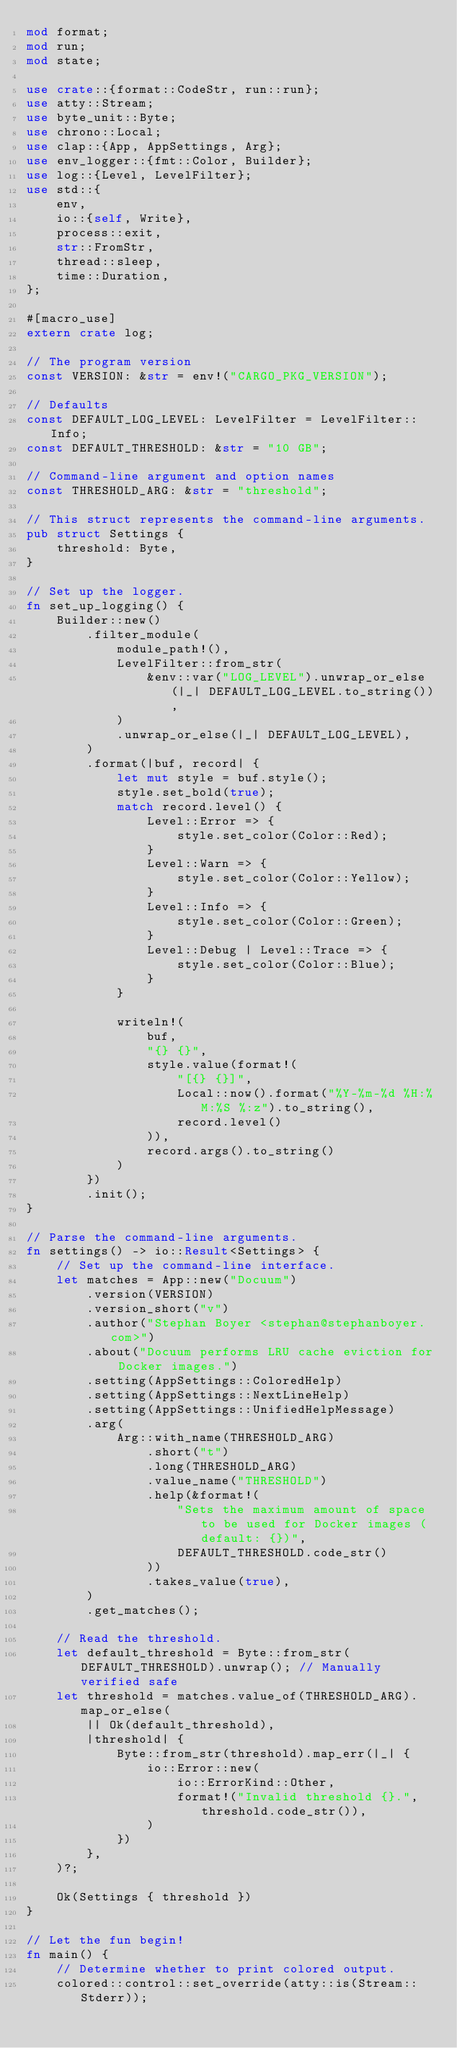Convert code to text. <code><loc_0><loc_0><loc_500><loc_500><_Rust_>mod format;
mod run;
mod state;

use crate::{format::CodeStr, run::run};
use atty::Stream;
use byte_unit::Byte;
use chrono::Local;
use clap::{App, AppSettings, Arg};
use env_logger::{fmt::Color, Builder};
use log::{Level, LevelFilter};
use std::{
    env,
    io::{self, Write},
    process::exit,
    str::FromStr,
    thread::sleep,
    time::Duration,
};

#[macro_use]
extern crate log;

// The program version
const VERSION: &str = env!("CARGO_PKG_VERSION");

// Defaults
const DEFAULT_LOG_LEVEL: LevelFilter = LevelFilter::Info;
const DEFAULT_THRESHOLD: &str = "10 GB";

// Command-line argument and option names
const THRESHOLD_ARG: &str = "threshold";

// This struct represents the command-line arguments.
pub struct Settings {
    threshold: Byte,
}

// Set up the logger.
fn set_up_logging() {
    Builder::new()
        .filter_module(
            module_path!(),
            LevelFilter::from_str(
                &env::var("LOG_LEVEL").unwrap_or_else(|_| DEFAULT_LOG_LEVEL.to_string()),
            )
            .unwrap_or_else(|_| DEFAULT_LOG_LEVEL),
        )
        .format(|buf, record| {
            let mut style = buf.style();
            style.set_bold(true);
            match record.level() {
                Level::Error => {
                    style.set_color(Color::Red);
                }
                Level::Warn => {
                    style.set_color(Color::Yellow);
                }
                Level::Info => {
                    style.set_color(Color::Green);
                }
                Level::Debug | Level::Trace => {
                    style.set_color(Color::Blue);
                }
            }

            writeln!(
                buf,
                "{} {}",
                style.value(format!(
                    "[{} {}]",
                    Local::now().format("%Y-%m-%d %H:%M:%S %:z").to_string(),
                    record.level()
                )),
                record.args().to_string()
            )
        })
        .init();
}

// Parse the command-line arguments.
fn settings() -> io::Result<Settings> {
    // Set up the command-line interface.
    let matches = App::new("Docuum")
        .version(VERSION)
        .version_short("v")
        .author("Stephan Boyer <stephan@stephanboyer.com>")
        .about("Docuum performs LRU cache eviction for Docker images.")
        .setting(AppSettings::ColoredHelp)
        .setting(AppSettings::NextLineHelp)
        .setting(AppSettings::UnifiedHelpMessage)
        .arg(
            Arg::with_name(THRESHOLD_ARG)
                .short("t")
                .long(THRESHOLD_ARG)
                .value_name("THRESHOLD")
                .help(&format!(
                    "Sets the maximum amount of space to be used for Docker images (default: {})",
                    DEFAULT_THRESHOLD.code_str()
                ))
                .takes_value(true),
        )
        .get_matches();

    // Read the threshold.
    let default_threshold = Byte::from_str(DEFAULT_THRESHOLD).unwrap(); // Manually verified safe
    let threshold = matches.value_of(THRESHOLD_ARG).map_or_else(
        || Ok(default_threshold),
        |threshold| {
            Byte::from_str(threshold).map_err(|_| {
                io::Error::new(
                    io::ErrorKind::Other,
                    format!("Invalid threshold {}.", threshold.code_str()),
                )
            })
        },
    )?;

    Ok(Settings { threshold })
}

// Let the fun begin!
fn main() {
    // Determine whether to print colored output.
    colored::control::set_override(atty::is(Stream::Stderr));
</code> 